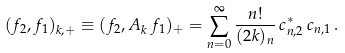<formula> <loc_0><loc_0><loc_500><loc_500>( f _ { 2 } , f _ { 1 } ) _ { k , + } \equiv ( f _ { 2 } , A _ { k } \, f _ { 1 } ) _ { + } = \sum _ { n = 0 } ^ { \infty } \frac { n ! } { ( 2 k ) _ { n } } \, c ^ { * } _ { n , 2 } \, c _ { n , 1 } \, .</formula> 